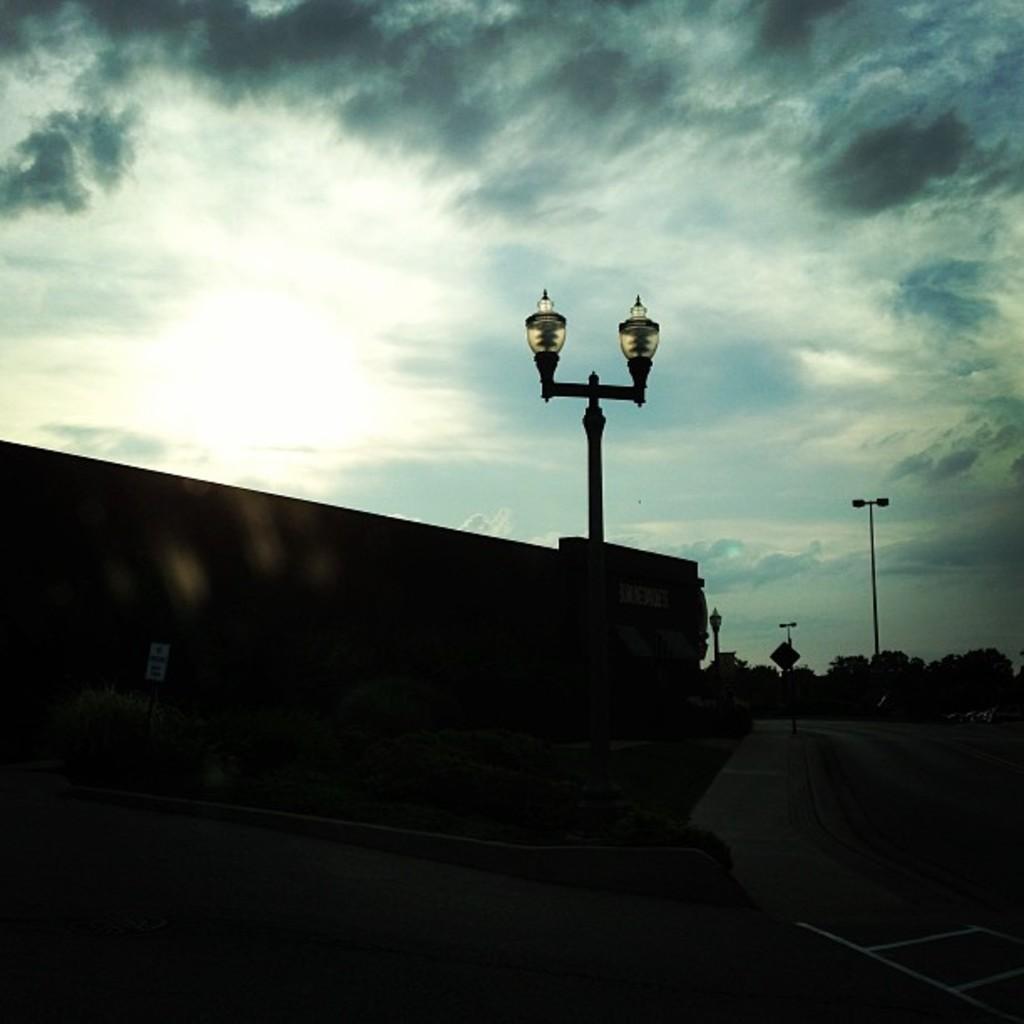Describe this image in one or two sentences. In this image In the middle there is a street light. In the background there is a pole, trees, sky and clouds. 